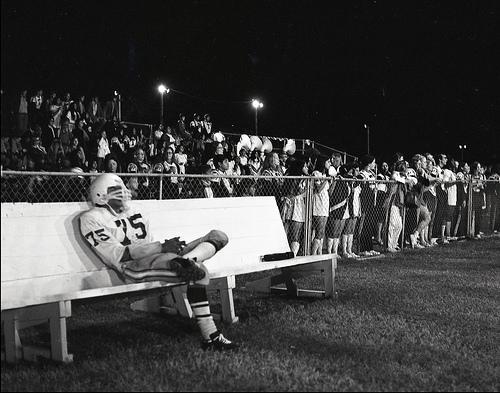How many people are infant of the fence?
Give a very brief answer. 1. 